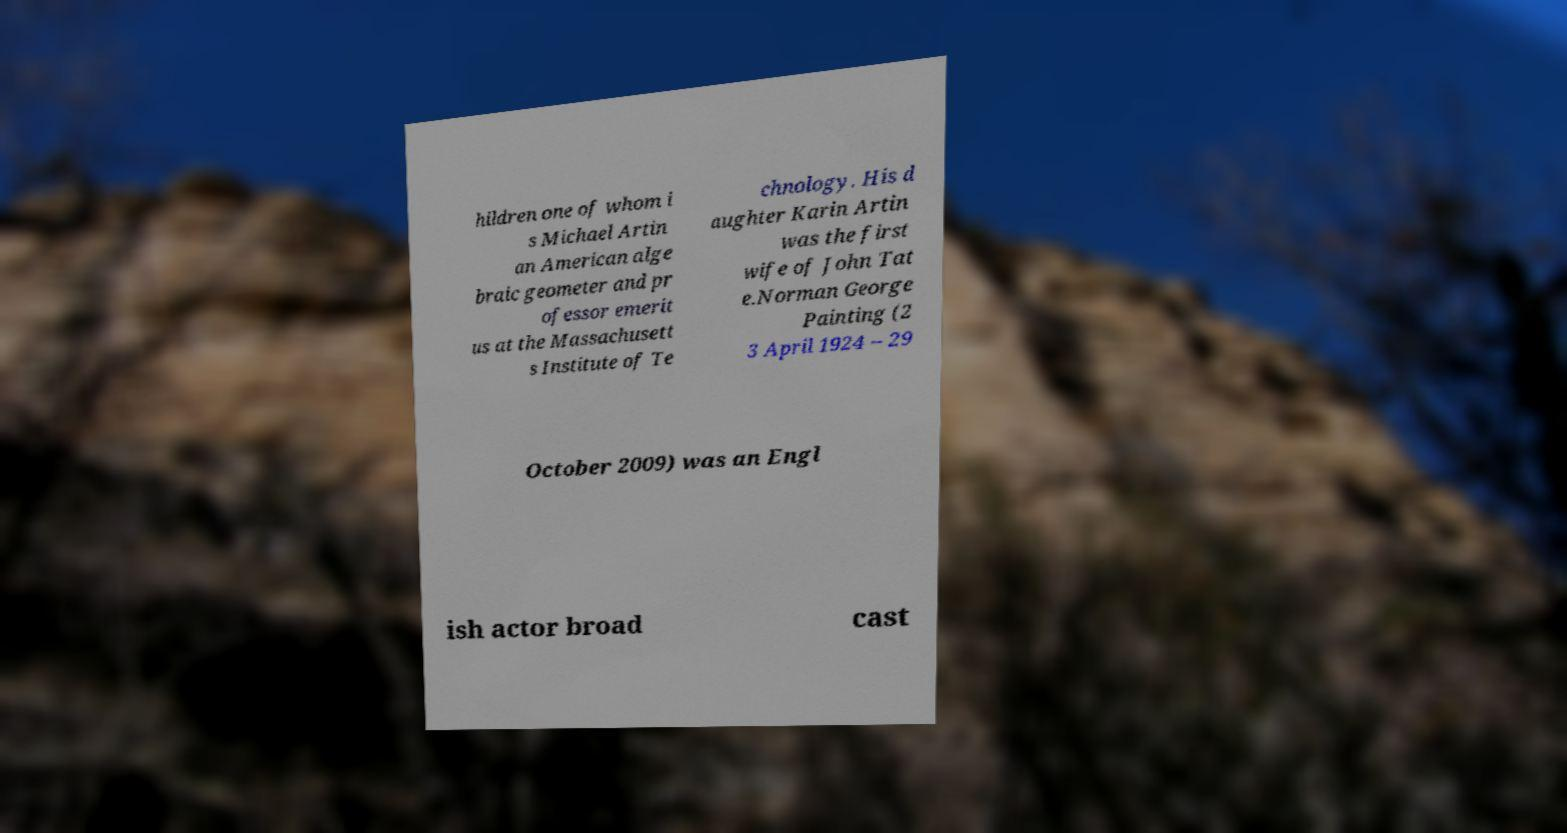Can you accurately transcribe the text from the provided image for me? hildren one of whom i s Michael Artin an American alge braic geometer and pr ofessor emerit us at the Massachusett s Institute of Te chnology. His d aughter Karin Artin was the first wife of John Tat e.Norman George Painting (2 3 April 1924 – 29 October 2009) was an Engl ish actor broad cast 